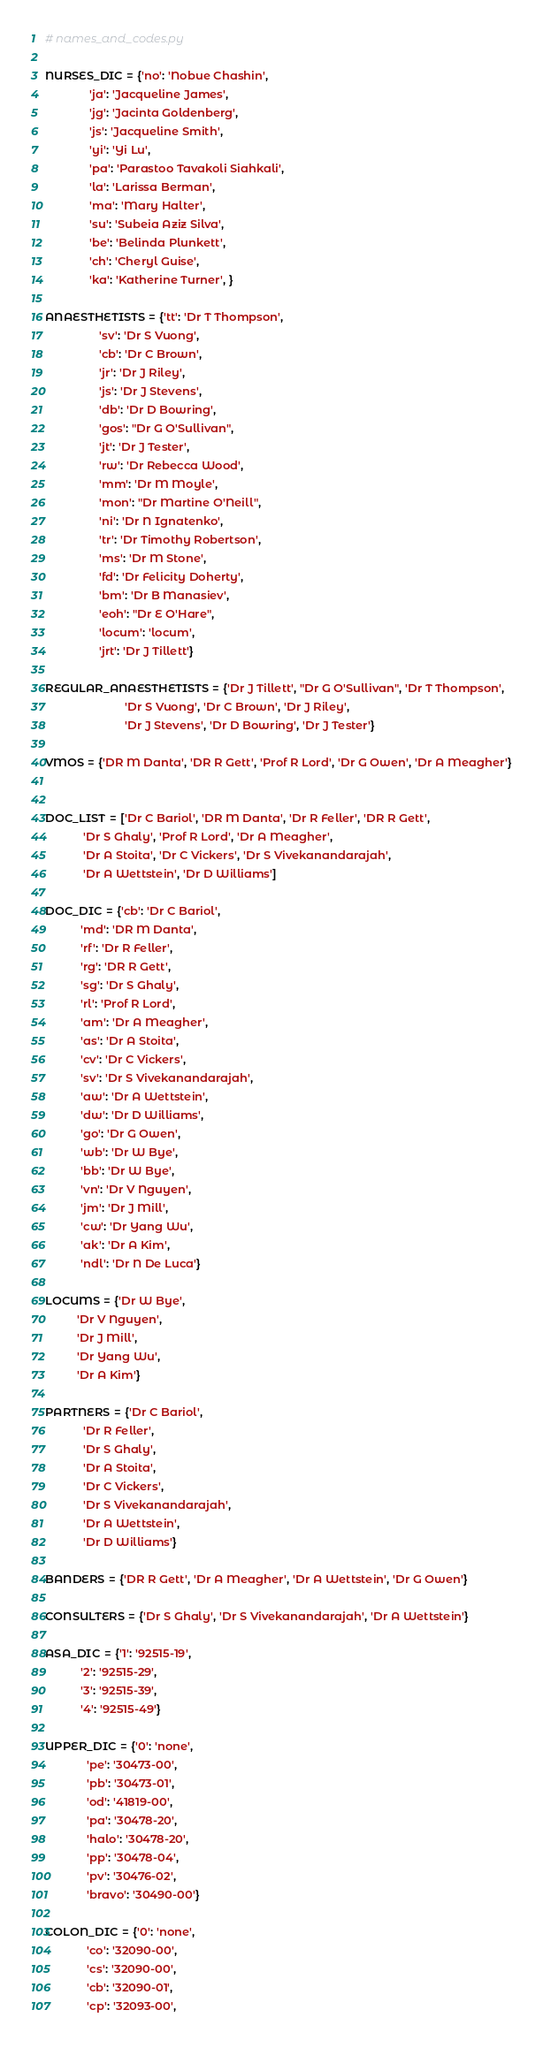Convert code to text. <code><loc_0><loc_0><loc_500><loc_500><_Python_># names_and_codes.py

NURSES_DIC = {'no': 'Nobue Chashin',
              'ja': 'Jacqueline James',
              'jg': 'Jacinta Goldenberg',
              'js': 'Jacqueline Smith',
              'yi': 'Yi Lu',
              'pa': 'Parastoo Tavakoli Siahkali',
              'la': 'Larissa Berman',
              'ma': 'Mary Halter',
              'su': 'Subeia Aziz Silva',
              'be': 'Belinda Plunkett',
              'ch': 'Cheryl Guise',
              'ka': 'Katherine Turner', }

ANAESTHETISTS = {'tt': 'Dr T Thompson',
                 'sv': 'Dr S Vuong',
                 'cb': 'Dr C Brown',
                 'jr': 'Dr J Riley',
                 'js': 'Dr J Stevens',
                 'db': 'Dr D Bowring',
                 'gos': "Dr G O'Sullivan",
                 'jt': 'Dr J Tester',
                 'rw': 'Dr Rebecca Wood',
                 'mm': 'Dr M Moyle',
                 'mon': "Dr Martine O'Neill",
                 'ni': 'Dr N Ignatenko',
                 'tr': 'Dr Timothy Robertson',
                 'ms': 'Dr M Stone',
                 'fd': 'Dr Felicity Doherty',
                 'bm': 'Dr B Manasiev',
                 'eoh': "Dr E O'Hare",
                 'locum': 'locum',
                 'jrt': 'Dr J Tillett'}

REGULAR_ANAESTHETISTS = {'Dr J Tillett', "Dr G O'Sullivan", 'Dr T Thompson',
                         'Dr S Vuong', 'Dr C Brown', 'Dr J Riley',
                         'Dr J Stevens', 'Dr D Bowring', 'Dr J Tester'}

VMOS = {'DR M Danta', 'DR R Gett', 'Prof R Lord', 'Dr G Owen', 'Dr A Meagher'}


DOC_LIST = ['Dr C Bariol', 'DR M Danta', 'Dr R Feller', 'DR R Gett',
            'Dr S Ghaly', 'Prof R Lord', 'Dr A Meagher',
            'Dr A Stoita', 'Dr C Vickers', 'Dr S Vivekanandarajah',
            'Dr A Wettstein', 'Dr D Williams']

DOC_DIC = {'cb': 'Dr C Bariol',
           'md': 'DR M Danta',
           'rf': 'Dr R Feller',
           'rg': 'DR R Gett',
           'sg': 'Dr S Ghaly',
           'rl': 'Prof R Lord',
           'am': 'Dr A Meagher',
           'as': 'Dr A Stoita',
           'cv': 'Dr C Vickers',
           'sv': 'Dr S Vivekanandarajah',
           'aw': 'Dr A Wettstein',
           'dw': 'Dr D Williams',
           'go': 'Dr G Owen',
           'wb': 'Dr W Bye',
           'bb': 'Dr W Bye',
           'vn': 'Dr V Nguyen',
           'jm': 'Dr J Mill',
           'cw': 'Dr Yang Wu',
           'ak': 'Dr A Kim',
           'ndl': 'Dr N De Luca'}

LOCUMS = {'Dr W Bye',
          'Dr V Nguyen',
          'Dr J Mill',
          'Dr Yang Wu',
          'Dr A Kim'}

PARTNERS = {'Dr C Bariol',
            'Dr R Feller',
            'Dr S Ghaly',
            'Dr A Stoita',
            'Dr C Vickers',
            'Dr S Vivekanandarajah',
            'Dr A Wettstein',
            'Dr D Williams'}

BANDERS = {'DR R Gett', 'Dr A Meagher', 'Dr A Wettstein', 'Dr G Owen'}

CONSULTERS = {'Dr S Ghaly', 'Dr S Vivekanandarajah', 'Dr A Wettstein'}

ASA_DIC = {'1': '92515-19',
           '2': '92515-29',
           '3': '92515-39',
           '4': '92515-49'}

UPPER_DIC = {'0': 'none',
             'pe': '30473-00',
             'pb': '30473-01',
             'od': '41819-00',
             'pa': '30478-20',
             'halo': '30478-20',
             'pp': '30478-04',
             'pv': '30476-02',
             'bravo': '30490-00'}

COLON_DIC = {'0': 'none',
             'co': '32090-00',
             'cs': '32090-00',
             'cb': '32090-01',
             'cp': '32093-00',</code> 